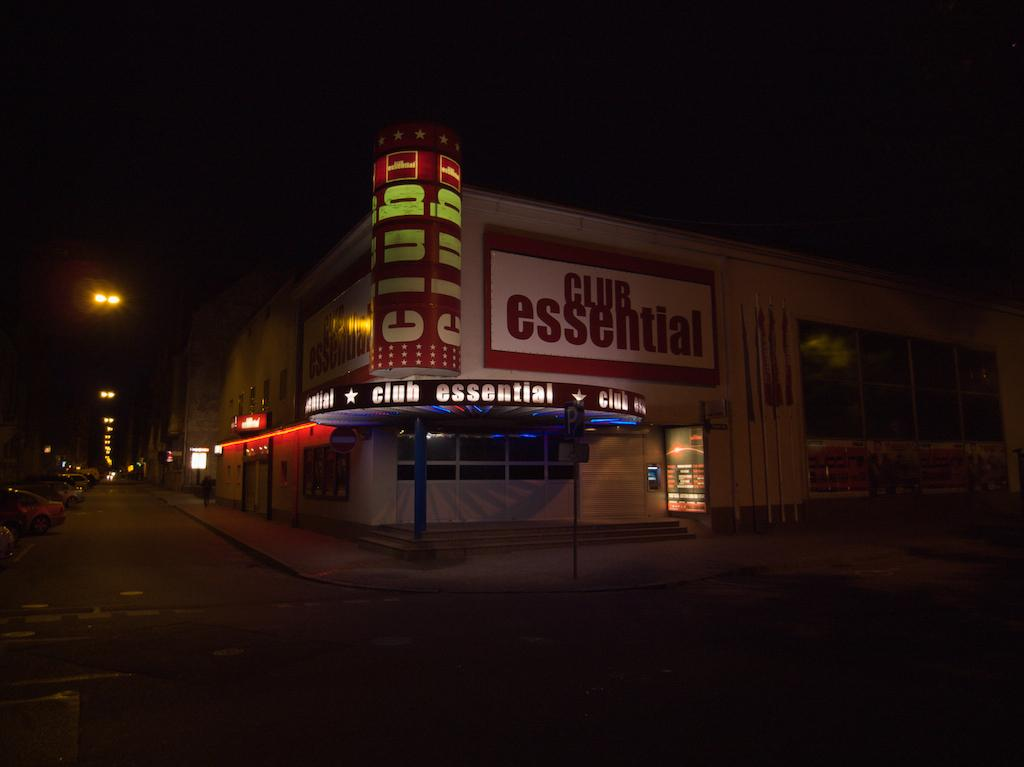What is the main structure in the foreground of the image? There is a building in the foreground of the image. What features can be seen on the building? Lights and doors are visible on the building in the foreground. What is attached to the building in the foreground? A board is visible in the foreground. What is happening on the road in the foreground? Fleets of cars are on the road in the foreground. What can be seen in the background of the image? The sky is visible in the background of the image. What time of day is the image taken? The image is taken during night. What type of pancake is being flipped by the hands in the image? There is no pancake or hands present in the image. How many frames are visible in the image? The image is a single photograph and does not contain multiple frames. 